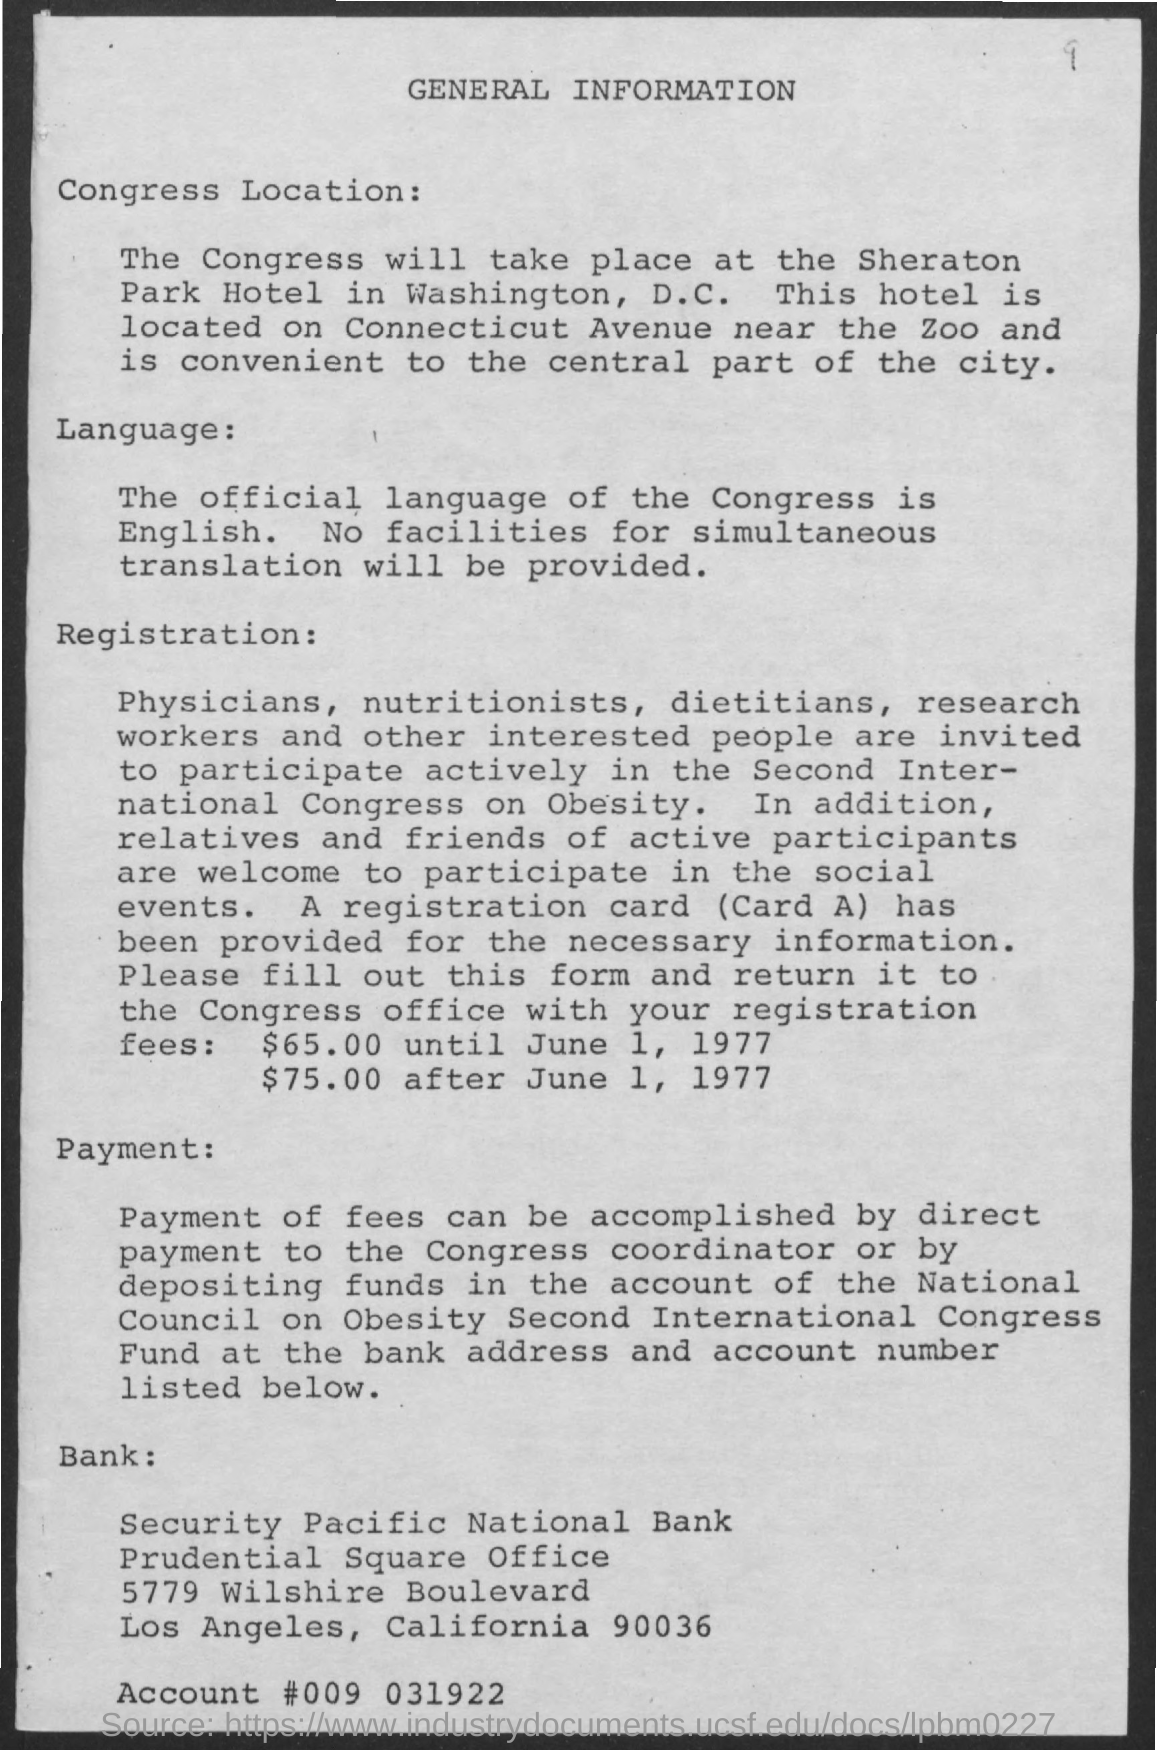What is the Title of the document?
Your response must be concise. General Information. What is the Official language of Congress?
Give a very brief answer. English. What is the Registration fees until June 1, 1977?
Provide a succinct answer. $65.00. What is the Registration fees after June 1, 1977?
Provide a succinct answer. $75.00. What is the Account #?
Keep it short and to the point. 009 031922. 